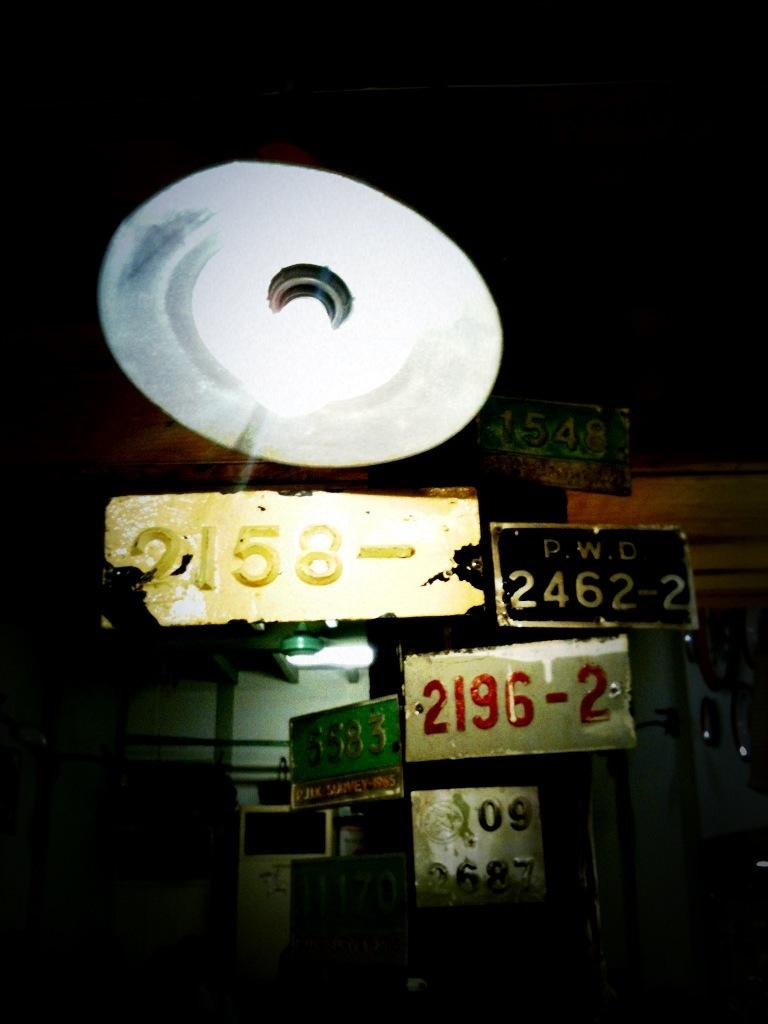<image>
Share a concise interpretation of the image provided. A black license plate has letters and numbers of PWD 2462-2. 